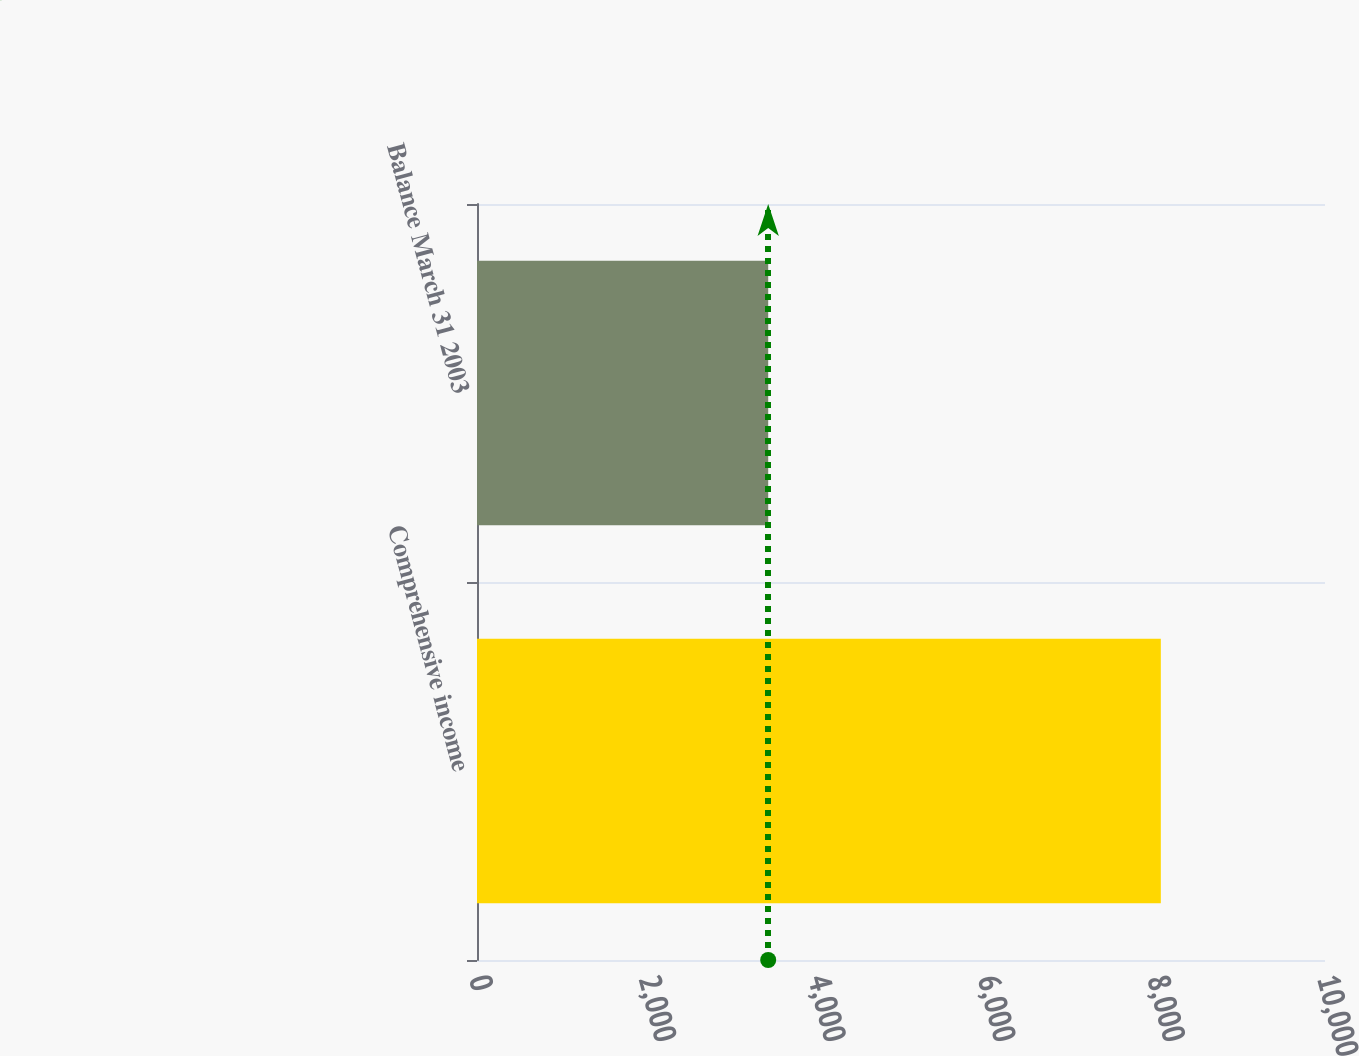Convert chart to OTSL. <chart><loc_0><loc_0><loc_500><loc_500><bar_chart><fcel>Comprehensive income<fcel>Balance March 31 2003<nl><fcel>8064<fcel>3434<nl></chart> 